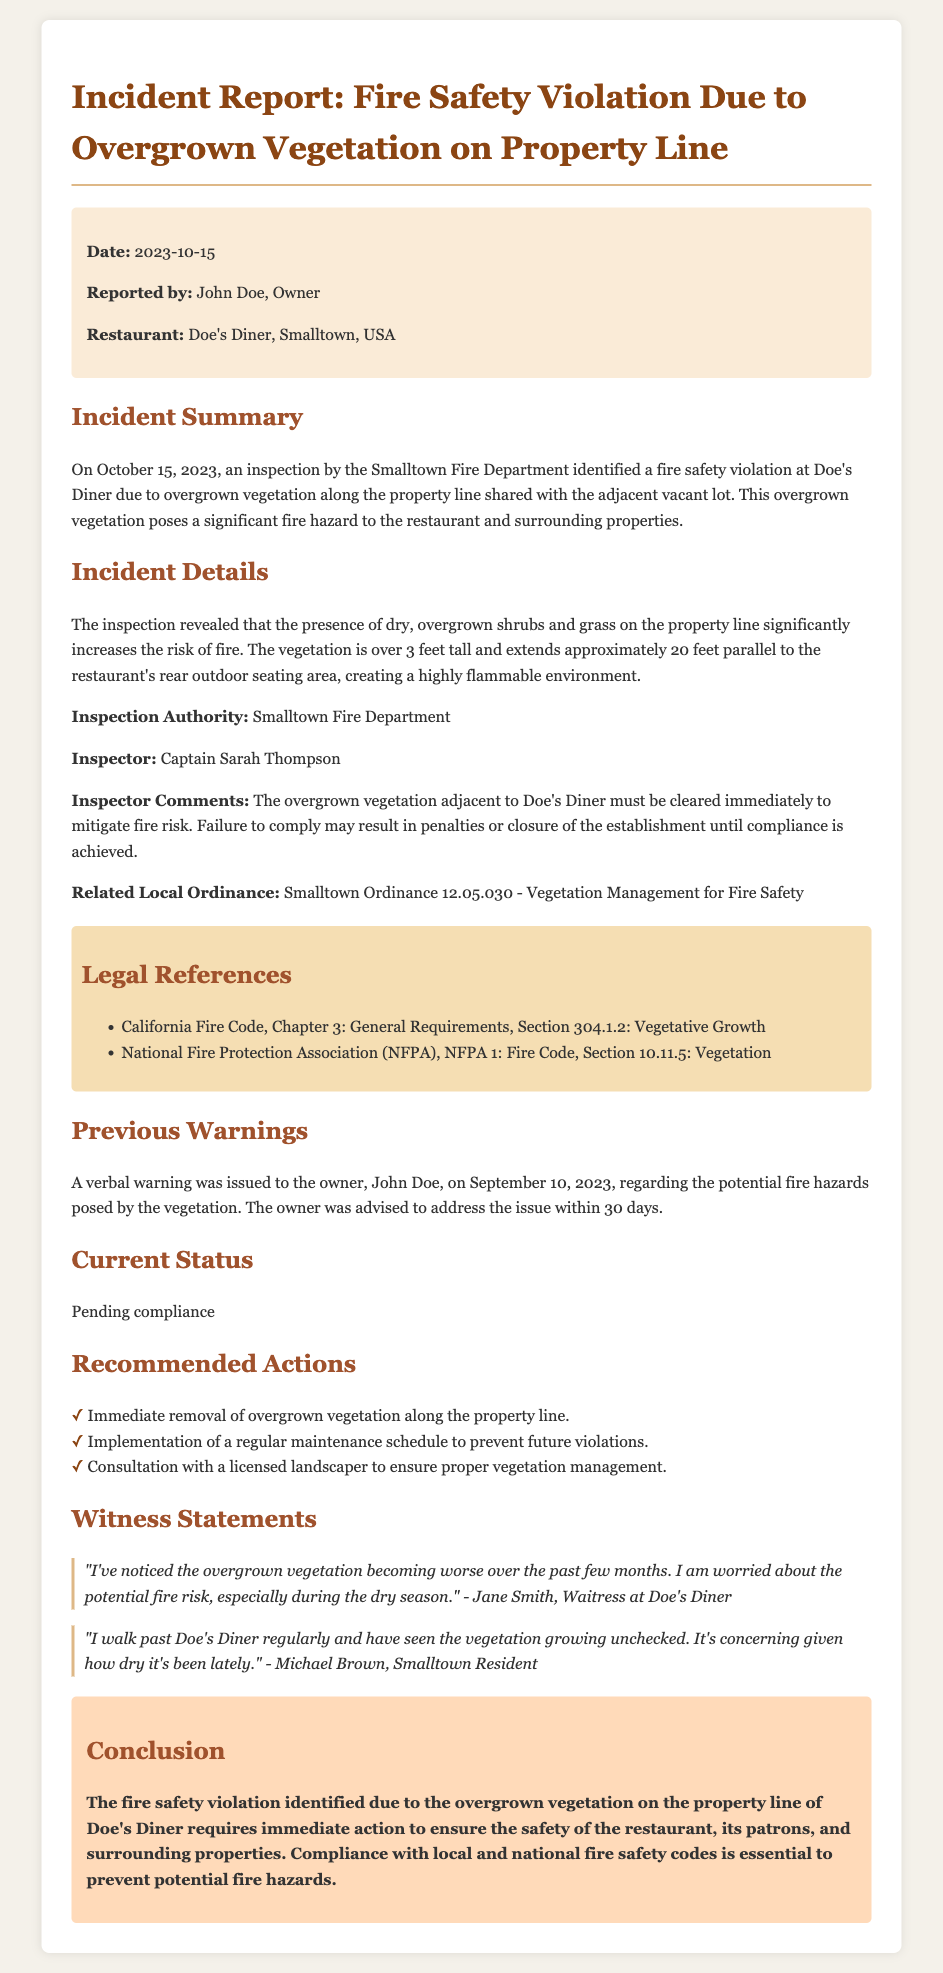What is the date of the incident report? The date is specified in the report header.
Answer: 2023-10-15 Who issued the inspection report? The report indicates who reported the issue.
Answer: John Doe What is the name of the restaurant involved? The document mentions the restaurant's name clearly.
Answer: Doe's Diner Who inspected the property? The name of the inspector is provided in the report details.
Answer: Captain Sarah Thompson What was identified as the fire hazard? The incident summary explains the primary concern of the report.
Answer: Overgrown vegetation What is the height of the overgrown vegetation? The report specifies the height of the vegetation during the inspection.
Answer: Over 3 feet What action is recommended to prevent future violations? The recommended actions section includes a preventive measure.
Answer: Implementation of a regular maintenance schedule What ordinance is related to this incident? The report includes a reference to a local ordinance regarding vegetation.
Answer: Smalltown Ordinance 12.05.030 What was the previous warning date? The document states when the verbal warning was issued.
Answer: September 10, 2023 What statement did Jane Smith make? Witness statements include specific remarks from employees.
Answer: "I've noticed the overgrown vegetation becoming worse over the past few months." 